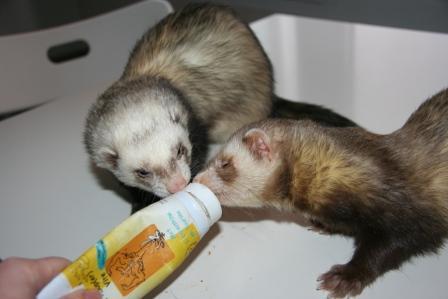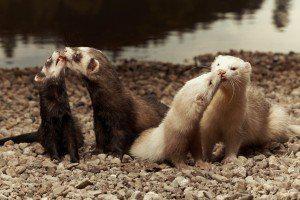The first image is the image on the left, the second image is the image on the right. Evaluate the accuracy of this statement regarding the images: "There are more than 4 ferrets interacting.". Is it true? Answer yes or no. Yes. The first image is the image on the left, the second image is the image on the right. Examine the images to the left and right. Is the description "At least two ferrets are playing." accurate? Answer yes or no. Yes. 